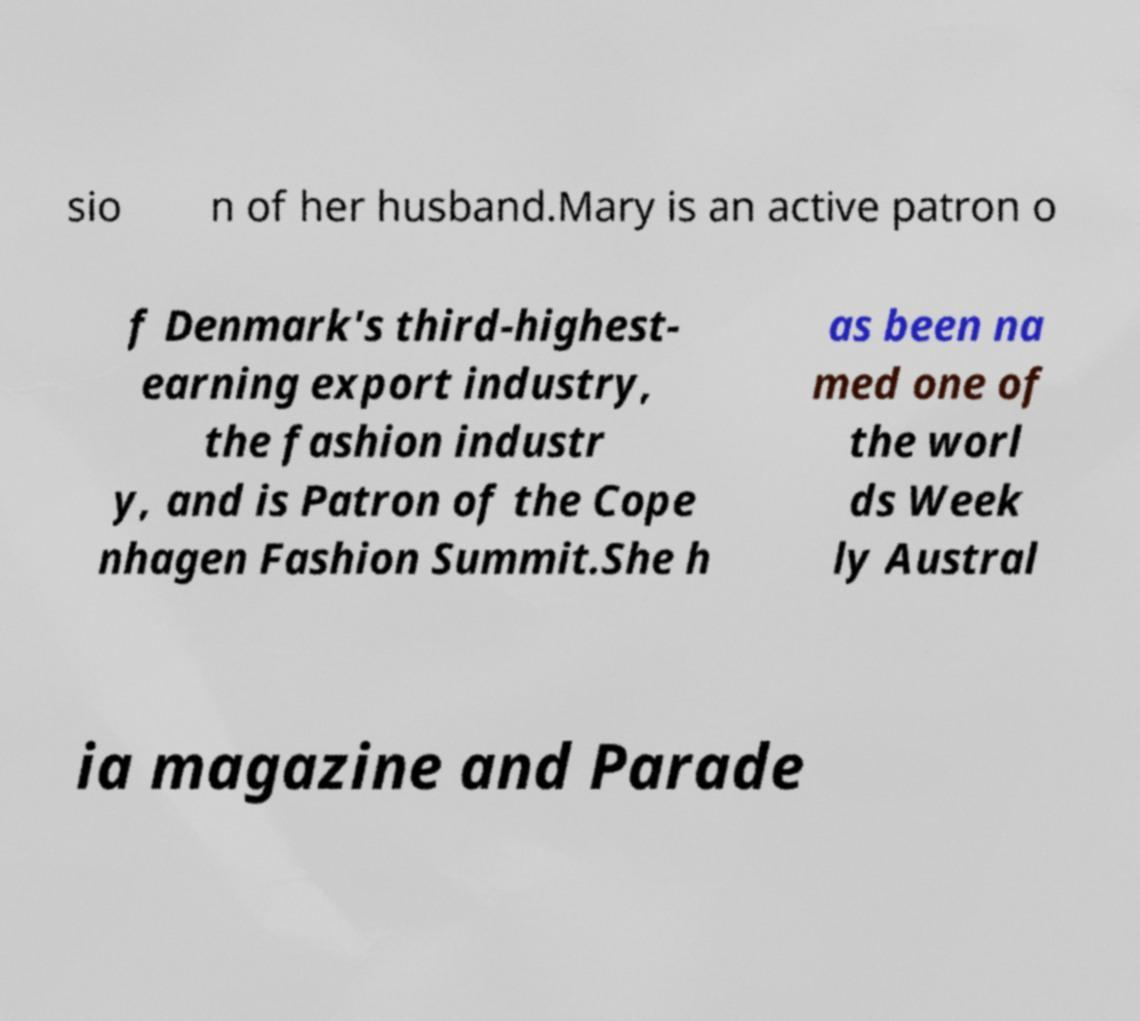Could you assist in decoding the text presented in this image and type it out clearly? sio n of her husband.Mary is an active patron o f Denmark's third-highest- earning export industry, the fashion industr y, and is Patron of the Cope nhagen Fashion Summit.She h as been na med one of the worl ds Week ly Austral ia magazine and Parade 